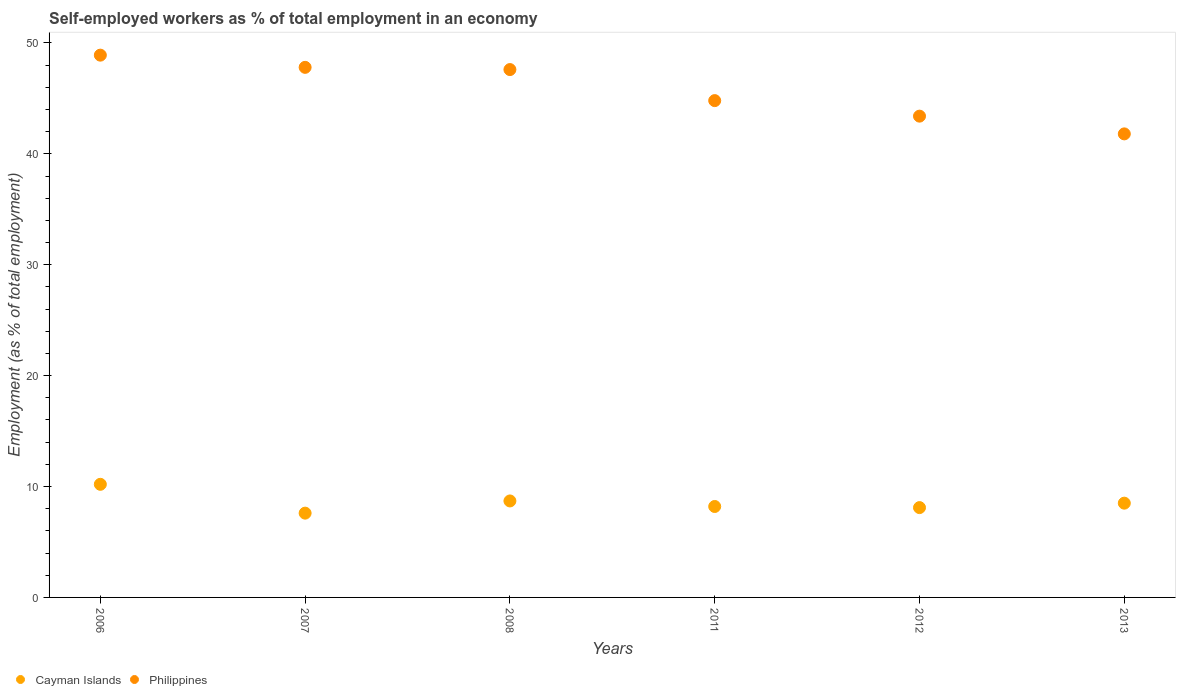What is the percentage of self-employed workers in Philippines in 2011?
Ensure brevity in your answer.  44.8. Across all years, what is the maximum percentage of self-employed workers in Philippines?
Provide a succinct answer. 48.9. Across all years, what is the minimum percentage of self-employed workers in Cayman Islands?
Ensure brevity in your answer.  7.6. What is the total percentage of self-employed workers in Philippines in the graph?
Make the answer very short. 274.3. What is the difference between the percentage of self-employed workers in Philippines in 2008 and that in 2013?
Provide a succinct answer. 5.8. What is the difference between the percentage of self-employed workers in Cayman Islands in 2006 and the percentage of self-employed workers in Philippines in 2008?
Give a very brief answer. -37.4. What is the average percentage of self-employed workers in Philippines per year?
Give a very brief answer. 45.72. In the year 2011, what is the difference between the percentage of self-employed workers in Cayman Islands and percentage of self-employed workers in Philippines?
Offer a very short reply. -36.6. What is the ratio of the percentage of self-employed workers in Cayman Islands in 2006 to that in 2007?
Your response must be concise. 1.34. Is the percentage of self-employed workers in Cayman Islands in 2007 less than that in 2012?
Keep it short and to the point. Yes. What is the difference between the highest and the second highest percentage of self-employed workers in Philippines?
Your response must be concise. 1.1. What is the difference between the highest and the lowest percentage of self-employed workers in Cayman Islands?
Provide a short and direct response. 2.6. In how many years, is the percentage of self-employed workers in Philippines greater than the average percentage of self-employed workers in Philippines taken over all years?
Ensure brevity in your answer.  3. Is the sum of the percentage of self-employed workers in Philippines in 2012 and 2013 greater than the maximum percentage of self-employed workers in Cayman Islands across all years?
Keep it short and to the point. Yes. Is the percentage of self-employed workers in Cayman Islands strictly less than the percentage of self-employed workers in Philippines over the years?
Ensure brevity in your answer.  Yes. Are the values on the major ticks of Y-axis written in scientific E-notation?
Give a very brief answer. No. Where does the legend appear in the graph?
Give a very brief answer. Bottom left. What is the title of the graph?
Your response must be concise. Self-employed workers as % of total employment in an economy. What is the label or title of the X-axis?
Your answer should be compact. Years. What is the label or title of the Y-axis?
Offer a very short reply. Employment (as % of total employment). What is the Employment (as % of total employment) in Cayman Islands in 2006?
Ensure brevity in your answer.  10.2. What is the Employment (as % of total employment) in Philippines in 2006?
Make the answer very short. 48.9. What is the Employment (as % of total employment) of Cayman Islands in 2007?
Your response must be concise. 7.6. What is the Employment (as % of total employment) in Philippines in 2007?
Your answer should be compact. 47.8. What is the Employment (as % of total employment) of Cayman Islands in 2008?
Provide a short and direct response. 8.7. What is the Employment (as % of total employment) in Philippines in 2008?
Give a very brief answer. 47.6. What is the Employment (as % of total employment) of Cayman Islands in 2011?
Provide a short and direct response. 8.2. What is the Employment (as % of total employment) of Philippines in 2011?
Keep it short and to the point. 44.8. What is the Employment (as % of total employment) of Cayman Islands in 2012?
Your answer should be compact. 8.1. What is the Employment (as % of total employment) of Philippines in 2012?
Keep it short and to the point. 43.4. What is the Employment (as % of total employment) in Philippines in 2013?
Provide a short and direct response. 41.8. Across all years, what is the maximum Employment (as % of total employment) of Cayman Islands?
Offer a terse response. 10.2. Across all years, what is the maximum Employment (as % of total employment) of Philippines?
Keep it short and to the point. 48.9. Across all years, what is the minimum Employment (as % of total employment) of Cayman Islands?
Offer a very short reply. 7.6. Across all years, what is the minimum Employment (as % of total employment) in Philippines?
Keep it short and to the point. 41.8. What is the total Employment (as % of total employment) in Cayman Islands in the graph?
Provide a succinct answer. 51.3. What is the total Employment (as % of total employment) of Philippines in the graph?
Keep it short and to the point. 274.3. What is the difference between the Employment (as % of total employment) of Cayman Islands in 2006 and that in 2007?
Your answer should be very brief. 2.6. What is the difference between the Employment (as % of total employment) in Philippines in 2006 and that in 2007?
Keep it short and to the point. 1.1. What is the difference between the Employment (as % of total employment) of Cayman Islands in 2006 and that in 2008?
Ensure brevity in your answer.  1.5. What is the difference between the Employment (as % of total employment) of Philippines in 2006 and that in 2011?
Provide a short and direct response. 4.1. What is the difference between the Employment (as % of total employment) of Philippines in 2006 and that in 2012?
Ensure brevity in your answer.  5.5. What is the difference between the Employment (as % of total employment) of Philippines in 2006 and that in 2013?
Give a very brief answer. 7.1. What is the difference between the Employment (as % of total employment) of Cayman Islands in 2007 and that in 2008?
Your answer should be very brief. -1.1. What is the difference between the Employment (as % of total employment) of Philippines in 2007 and that in 2011?
Your answer should be very brief. 3. What is the difference between the Employment (as % of total employment) in Cayman Islands in 2007 and that in 2012?
Offer a terse response. -0.5. What is the difference between the Employment (as % of total employment) of Philippines in 2007 and that in 2012?
Make the answer very short. 4.4. What is the difference between the Employment (as % of total employment) in Cayman Islands in 2007 and that in 2013?
Offer a terse response. -0.9. What is the difference between the Employment (as % of total employment) in Philippines in 2007 and that in 2013?
Provide a short and direct response. 6. What is the difference between the Employment (as % of total employment) in Cayman Islands in 2008 and that in 2012?
Your answer should be compact. 0.6. What is the difference between the Employment (as % of total employment) in Cayman Islands in 2008 and that in 2013?
Your answer should be very brief. 0.2. What is the difference between the Employment (as % of total employment) in Philippines in 2011 and that in 2013?
Give a very brief answer. 3. What is the difference between the Employment (as % of total employment) in Cayman Islands in 2006 and the Employment (as % of total employment) in Philippines in 2007?
Your response must be concise. -37.6. What is the difference between the Employment (as % of total employment) in Cayman Islands in 2006 and the Employment (as % of total employment) in Philippines in 2008?
Your answer should be very brief. -37.4. What is the difference between the Employment (as % of total employment) in Cayman Islands in 2006 and the Employment (as % of total employment) in Philippines in 2011?
Offer a very short reply. -34.6. What is the difference between the Employment (as % of total employment) of Cayman Islands in 2006 and the Employment (as % of total employment) of Philippines in 2012?
Your answer should be compact. -33.2. What is the difference between the Employment (as % of total employment) of Cayman Islands in 2006 and the Employment (as % of total employment) of Philippines in 2013?
Provide a short and direct response. -31.6. What is the difference between the Employment (as % of total employment) of Cayman Islands in 2007 and the Employment (as % of total employment) of Philippines in 2008?
Your response must be concise. -40. What is the difference between the Employment (as % of total employment) in Cayman Islands in 2007 and the Employment (as % of total employment) in Philippines in 2011?
Your answer should be very brief. -37.2. What is the difference between the Employment (as % of total employment) of Cayman Islands in 2007 and the Employment (as % of total employment) of Philippines in 2012?
Ensure brevity in your answer.  -35.8. What is the difference between the Employment (as % of total employment) of Cayman Islands in 2007 and the Employment (as % of total employment) of Philippines in 2013?
Your answer should be compact. -34.2. What is the difference between the Employment (as % of total employment) of Cayman Islands in 2008 and the Employment (as % of total employment) of Philippines in 2011?
Make the answer very short. -36.1. What is the difference between the Employment (as % of total employment) in Cayman Islands in 2008 and the Employment (as % of total employment) in Philippines in 2012?
Provide a succinct answer. -34.7. What is the difference between the Employment (as % of total employment) in Cayman Islands in 2008 and the Employment (as % of total employment) in Philippines in 2013?
Give a very brief answer. -33.1. What is the difference between the Employment (as % of total employment) of Cayman Islands in 2011 and the Employment (as % of total employment) of Philippines in 2012?
Your answer should be very brief. -35.2. What is the difference between the Employment (as % of total employment) in Cayman Islands in 2011 and the Employment (as % of total employment) in Philippines in 2013?
Make the answer very short. -33.6. What is the difference between the Employment (as % of total employment) of Cayman Islands in 2012 and the Employment (as % of total employment) of Philippines in 2013?
Keep it short and to the point. -33.7. What is the average Employment (as % of total employment) of Cayman Islands per year?
Offer a terse response. 8.55. What is the average Employment (as % of total employment) in Philippines per year?
Give a very brief answer. 45.72. In the year 2006, what is the difference between the Employment (as % of total employment) in Cayman Islands and Employment (as % of total employment) in Philippines?
Your response must be concise. -38.7. In the year 2007, what is the difference between the Employment (as % of total employment) in Cayman Islands and Employment (as % of total employment) in Philippines?
Your answer should be compact. -40.2. In the year 2008, what is the difference between the Employment (as % of total employment) in Cayman Islands and Employment (as % of total employment) in Philippines?
Offer a very short reply. -38.9. In the year 2011, what is the difference between the Employment (as % of total employment) of Cayman Islands and Employment (as % of total employment) of Philippines?
Provide a succinct answer. -36.6. In the year 2012, what is the difference between the Employment (as % of total employment) of Cayman Islands and Employment (as % of total employment) of Philippines?
Offer a very short reply. -35.3. In the year 2013, what is the difference between the Employment (as % of total employment) in Cayman Islands and Employment (as % of total employment) in Philippines?
Keep it short and to the point. -33.3. What is the ratio of the Employment (as % of total employment) of Cayman Islands in 2006 to that in 2007?
Make the answer very short. 1.34. What is the ratio of the Employment (as % of total employment) of Cayman Islands in 2006 to that in 2008?
Give a very brief answer. 1.17. What is the ratio of the Employment (as % of total employment) in Philippines in 2006 to that in 2008?
Provide a short and direct response. 1.03. What is the ratio of the Employment (as % of total employment) in Cayman Islands in 2006 to that in 2011?
Your answer should be very brief. 1.24. What is the ratio of the Employment (as % of total employment) of Philippines in 2006 to that in 2011?
Your answer should be compact. 1.09. What is the ratio of the Employment (as % of total employment) of Cayman Islands in 2006 to that in 2012?
Ensure brevity in your answer.  1.26. What is the ratio of the Employment (as % of total employment) of Philippines in 2006 to that in 2012?
Ensure brevity in your answer.  1.13. What is the ratio of the Employment (as % of total employment) in Cayman Islands in 2006 to that in 2013?
Ensure brevity in your answer.  1.2. What is the ratio of the Employment (as % of total employment) of Philippines in 2006 to that in 2013?
Provide a short and direct response. 1.17. What is the ratio of the Employment (as % of total employment) of Cayman Islands in 2007 to that in 2008?
Offer a terse response. 0.87. What is the ratio of the Employment (as % of total employment) of Philippines in 2007 to that in 2008?
Your response must be concise. 1. What is the ratio of the Employment (as % of total employment) in Cayman Islands in 2007 to that in 2011?
Your answer should be very brief. 0.93. What is the ratio of the Employment (as % of total employment) of Philippines in 2007 to that in 2011?
Your answer should be very brief. 1.07. What is the ratio of the Employment (as % of total employment) of Cayman Islands in 2007 to that in 2012?
Offer a terse response. 0.94. What is the ratio of the Employment (as % of total employment) in Philippines in 2007 to that in 2012?
Provide a succinct answer. 1.1. What is the ratio of the Employment (as % of total employment) in Cayman Islands in 2007 to that in 2013?
Ensure brevity in your answer.  0.89. What is the ratio of the Employment (as % of total employment) in Philippines in 2007 to that in 2013?
Give a very brief answer. 1.14. What is the ratio of the Employment (as % of total employment) of Cayman Islands in 2008 to that in 2011?
Keep it short and to the point. 1.06. What is the ratio of the Employment (as % of total employment) in Cayman Islands in 2008 to that in 2012?
Offer a terse response. 1.07. What is the ratio of the Employment (as % of total employment) in Philippines in 2008 to that in 2012?
Your response must be concise. 1.1. What is the ratio of the Employment (as % of total employment) of Cayman Islands in 2008 to that in 2013?
Provide a succinct answer. 1.02. What is the ratio of the Employment (as % of total employment) of Philippines in 2008 to that in 2013?
Offer a terse response. 1.14. What is the ratio of the Employment (as % of total employment) in Cayman Islands in 2011 to that in 2012?
Offer a terse response. 1.01. What is the ratio of the Employment (as % of total employment) in Philippines in 2011 to that in 2012?
Your answer should be compact. 1.03. What is the ratio of the Employment (as % of total employment) in Cayman Islands in 2011 to that in 2013?
Your response must be concise. 0.96. What is the ratio of the Employment (as % of total employment) of Philippines in 2011 to that in 2013?
Provide a short and direct response. 1.07. What is the ratio of the Employment (as % of total employment) in Cayman Islands in 2012 to that in 2013?
Offer a very short reply. 0.95. What is the ratio of the Employment (as % of total employment) in Philippines in 2012 to that in 2013?
Provide a succinct answer. 1.04. What is the difference between the highest and the second highest Employment (as % of total employment) of Philippines?
Keep it short and to the point. 1.1. 